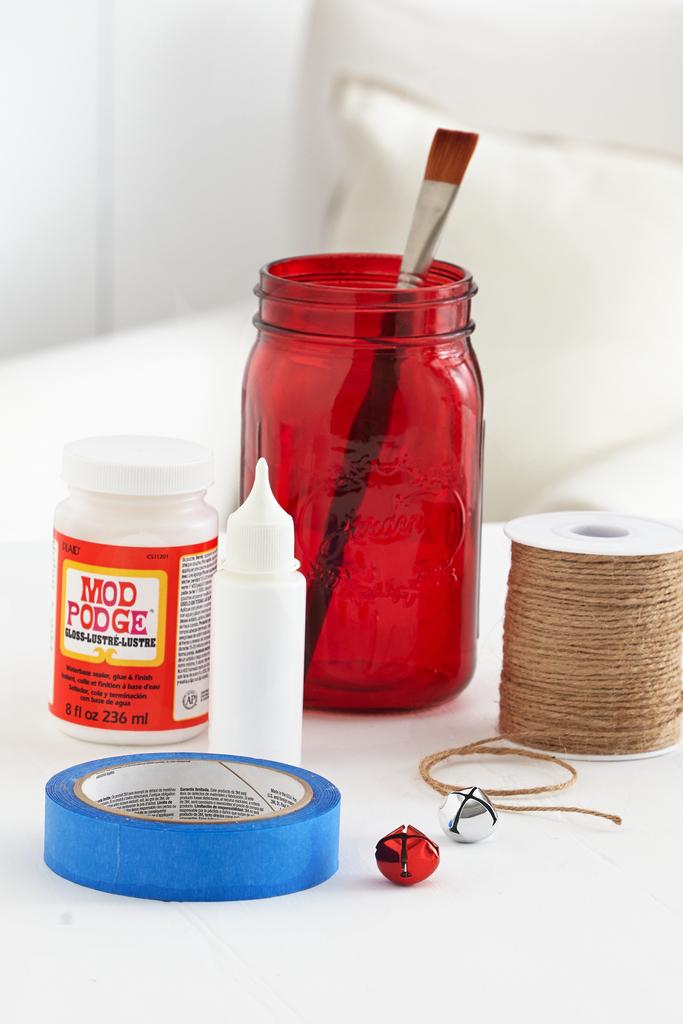What is the name on the bottle?
Keep it short and to the point. Mod podge. What brand is on the orange bottle?
Ensure brevity in your answer.  Mod podge. 